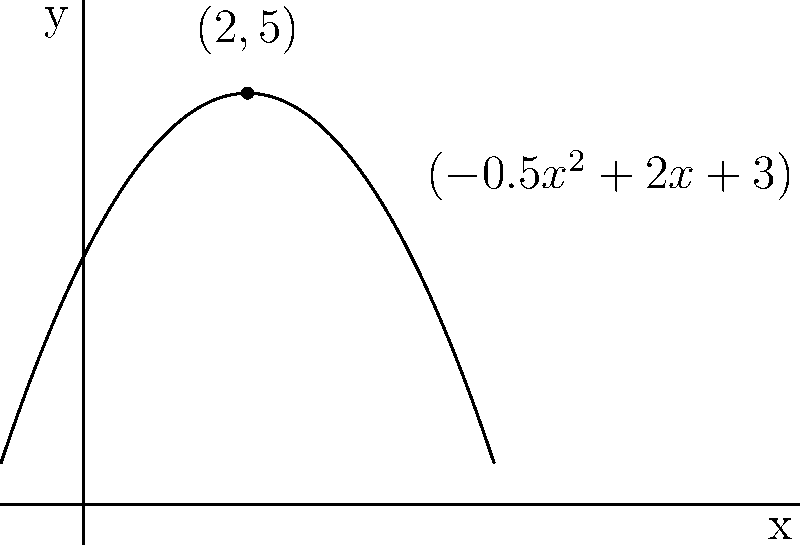As you organize books on a curved shelf that resembles a cat's arched back, you notice the shelf's shape can be described by the polynomial function $f(x) = -0.5x^2 + 2x + 3$. At which point does this shelf reach its maximum height, allowing you to place your favorite feline-themed novel? To find the maximum point of this polynomial function, we can follow these steps:

1) The function $f(x) = -0.5x^2 + 2x + 3$ is a quadratic function, which forms a parabola.

2) For a quadratic function in the form $f(x) = ax^2 + bx + c$, the x-coordinate of the vertex (maximum or minimum point) is given by $x = -\frac{b}{2a}$.

3) In this case, $a = -0.5$ and $b = 2$.

4) Plugging these values into the formula:
   $x = -\frac{2}{2(-0.5)} = -\frac{2}{-1} = 2$

5) To find the y-coordinate, we substitute x = 2 into the original function:
   $f(2) = -0.5(2)^2 + 2(2) + 3$
         $= -0.5(4) + 4 + 3$
         $= -2 + 4 + 3$
         $= 5$

6) Therefore, the maximum point is at (2, 5).

This point represents the highest part of your cat-back-shaped shelf, perfect for showcasing your favorite book!
Answer: (2, 5) 